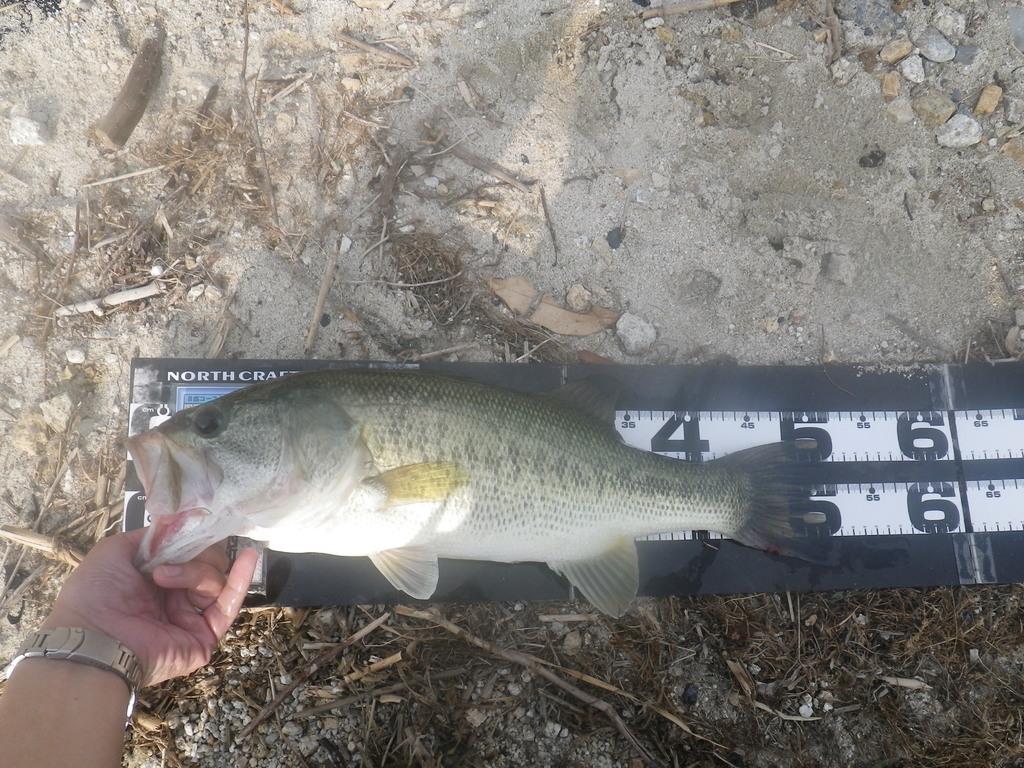Please provide a concise description of this image. We can see a person hand holding a fish,under the fish we can see scale and we can see stones,sand and sticks. 